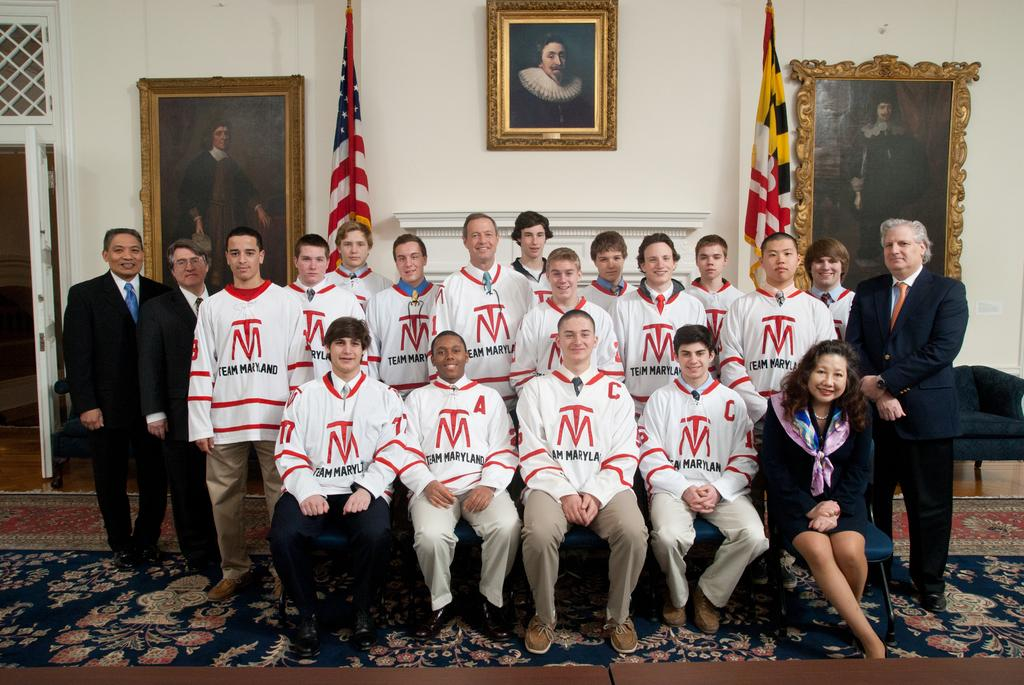<image>
Give a short and clear explanation of the subsequent image. the letter M that is on the front of a shirt 